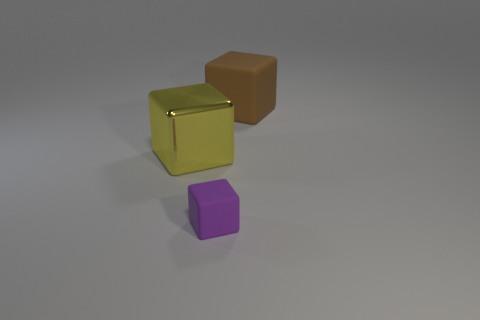Is the large object left of the brown thing made of the same material as the purple thing? Given the appearance in the image, the large object to the left of the brown cube, which is golden, does not seem to be made of the same material as the purple cube. The golden object has a reflective metallic look, while the purple object appears to have a matte finish, suggesting they could be made from different materials. 